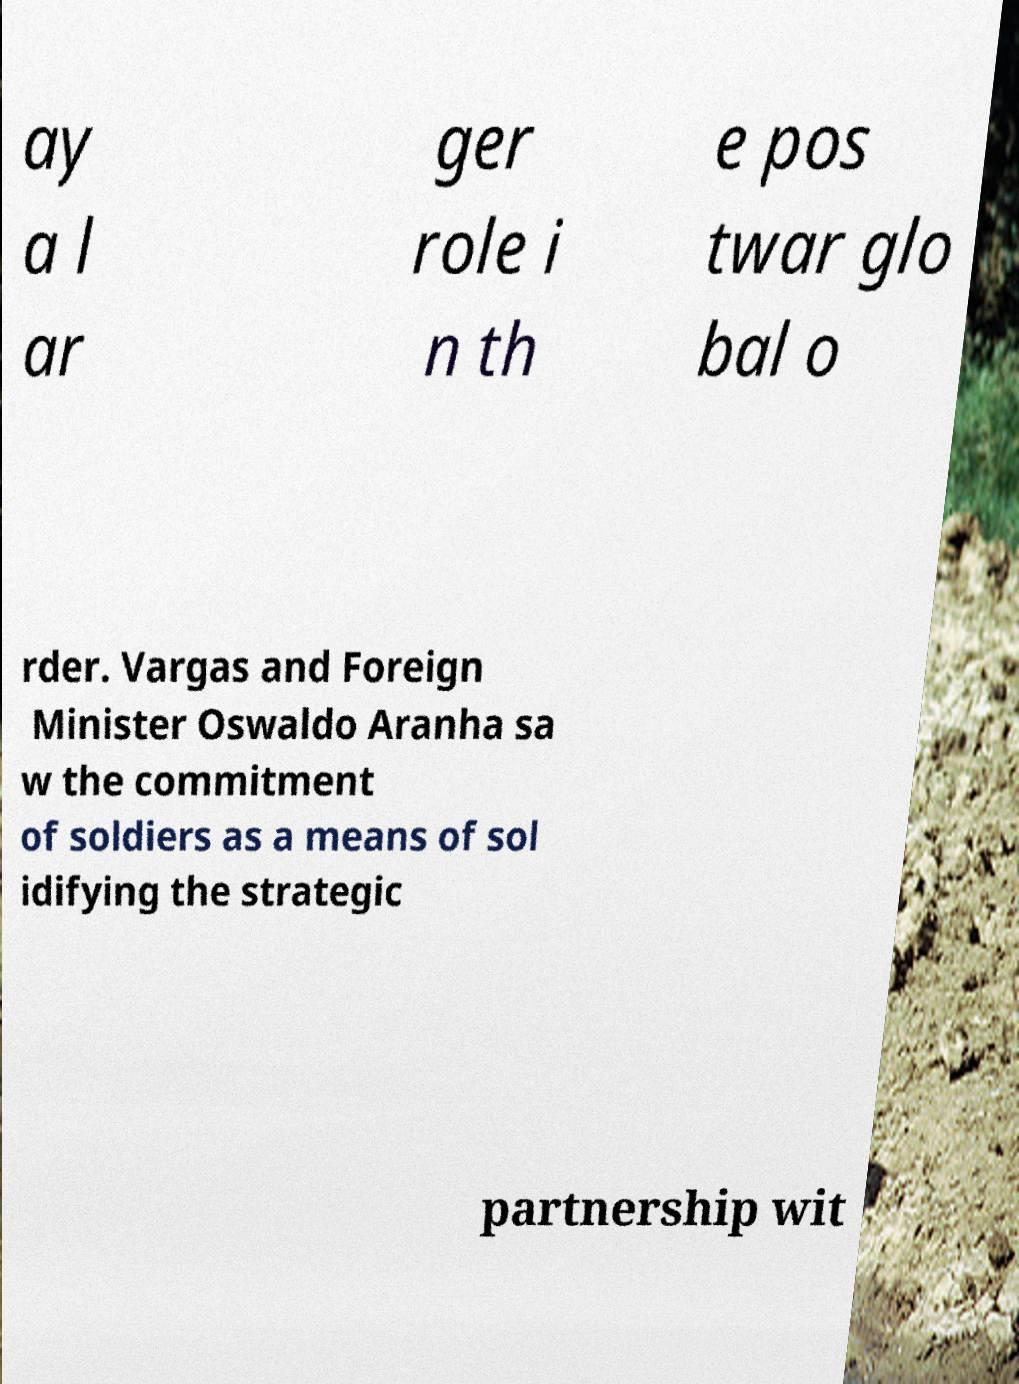Can you accurately transcribe the text from the provided image for me? ay a l ar ger role i n th e pos twar glo bal o rder. Vargas and Foreign Minister Oswaldo Aranha sa w the commitment of soldiers as a means of sol idifying the strategic partnership wit 